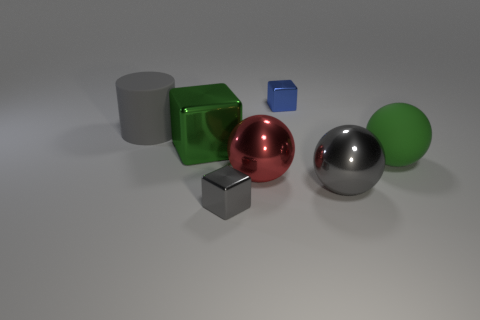There is a thing that is both behind the large red thing and in front of the green shiny object; what material is it?
Give a very brief answer. Rubber. Is the size of the green object on the right side of the green metal cube the same as the tiny blue metallic object?
Your response must be concise. No. What material is the small blue object?
Your answer should be very brief. Metal. There is a small cube behind the big gray ball; what color is it?
Ensure brevity in your answer.  Blue. What number of tiny objects are either gray metal blocks or cyan cubes?
Offer a terse response. 1. There is a big matte object that is in front of the big cylinder; does it have the same color as the large cube that is on the left side of the blue metal object?
Provide a succinct answer. Yes. What number of other objects are there of the same color as the big matte ball?
Provide a succinct answer. 1. What number of gray objects are large metallic spheres or rubber spheres?
Your answer should be very brief. 1. There is a large gray metallic thing; is its shape the same as the big green object to the right of the red thing?
Your answer should be very brief. Yes. The small gray metal object is what shape?
Offer a very short reply. Cube. 